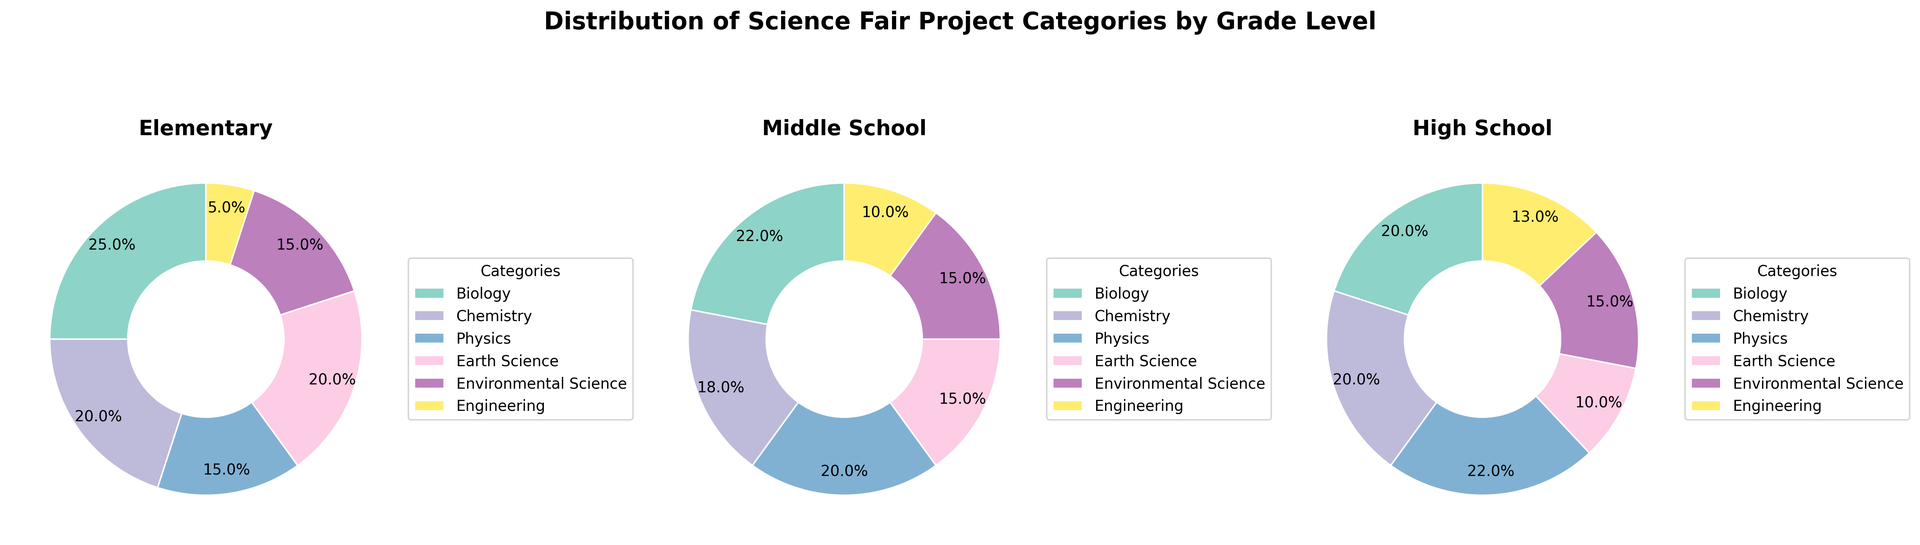What category has the largest percentage of projects in the Elementary grade? The largest segment on the pie chart for Elementary grade corresponds to Biology at 25%.
Answer: Biology Which grade level has the highest percentage of Physics projects? Comparing the Physics segments across the three charts, the High School chart shows the highest percentage at 22%.
Answer: High School What is the combined percentage of Earth Science and Environmental Science projects for Middle School? The segments for Earth Science and Environmental Science in the Middle School pie chart are both 15%. Adding them together gives 15% + 15% = 30%.
Answer: 30% Is the percentage of Chemistry projects equal at any two grade levels? Checking the Chemistry segments, the Elementary and High School charts both show 20% for Chemistry.
Answer: Yes Between Elementary and Middle School, which has a higher percentage of Engineering projects, and by how much? The Elementary chart shows 5% for Engineering while the Middle School chart shows 10%. The difference is 10% - 5% = 5%. Middle School has a 5% higher percentage of Engineering projects.
Answer: Middle School, 5% What is the average percentage of Biology projects across all three grade levels? The percentages for Biology in Elementary, Middle School, and High School are 25%, 22%, and 20%, respectively. The average is (25% + 22% + 20%)/3 = 22.33%
Answer: 22.33% What percentage of projects belong to Physics and Chemistry combined in High School? The High School chart shows 22% for Physics and 20% for Chemistry. Adding these percentages together gives 22% + 20% = 42%.
Answer: 42% Which category has the smallest percentage of projects in Elementary grade? The smallest segment in the Elementary grade chart is for Engineering at 5%.
Answer: Engineering 